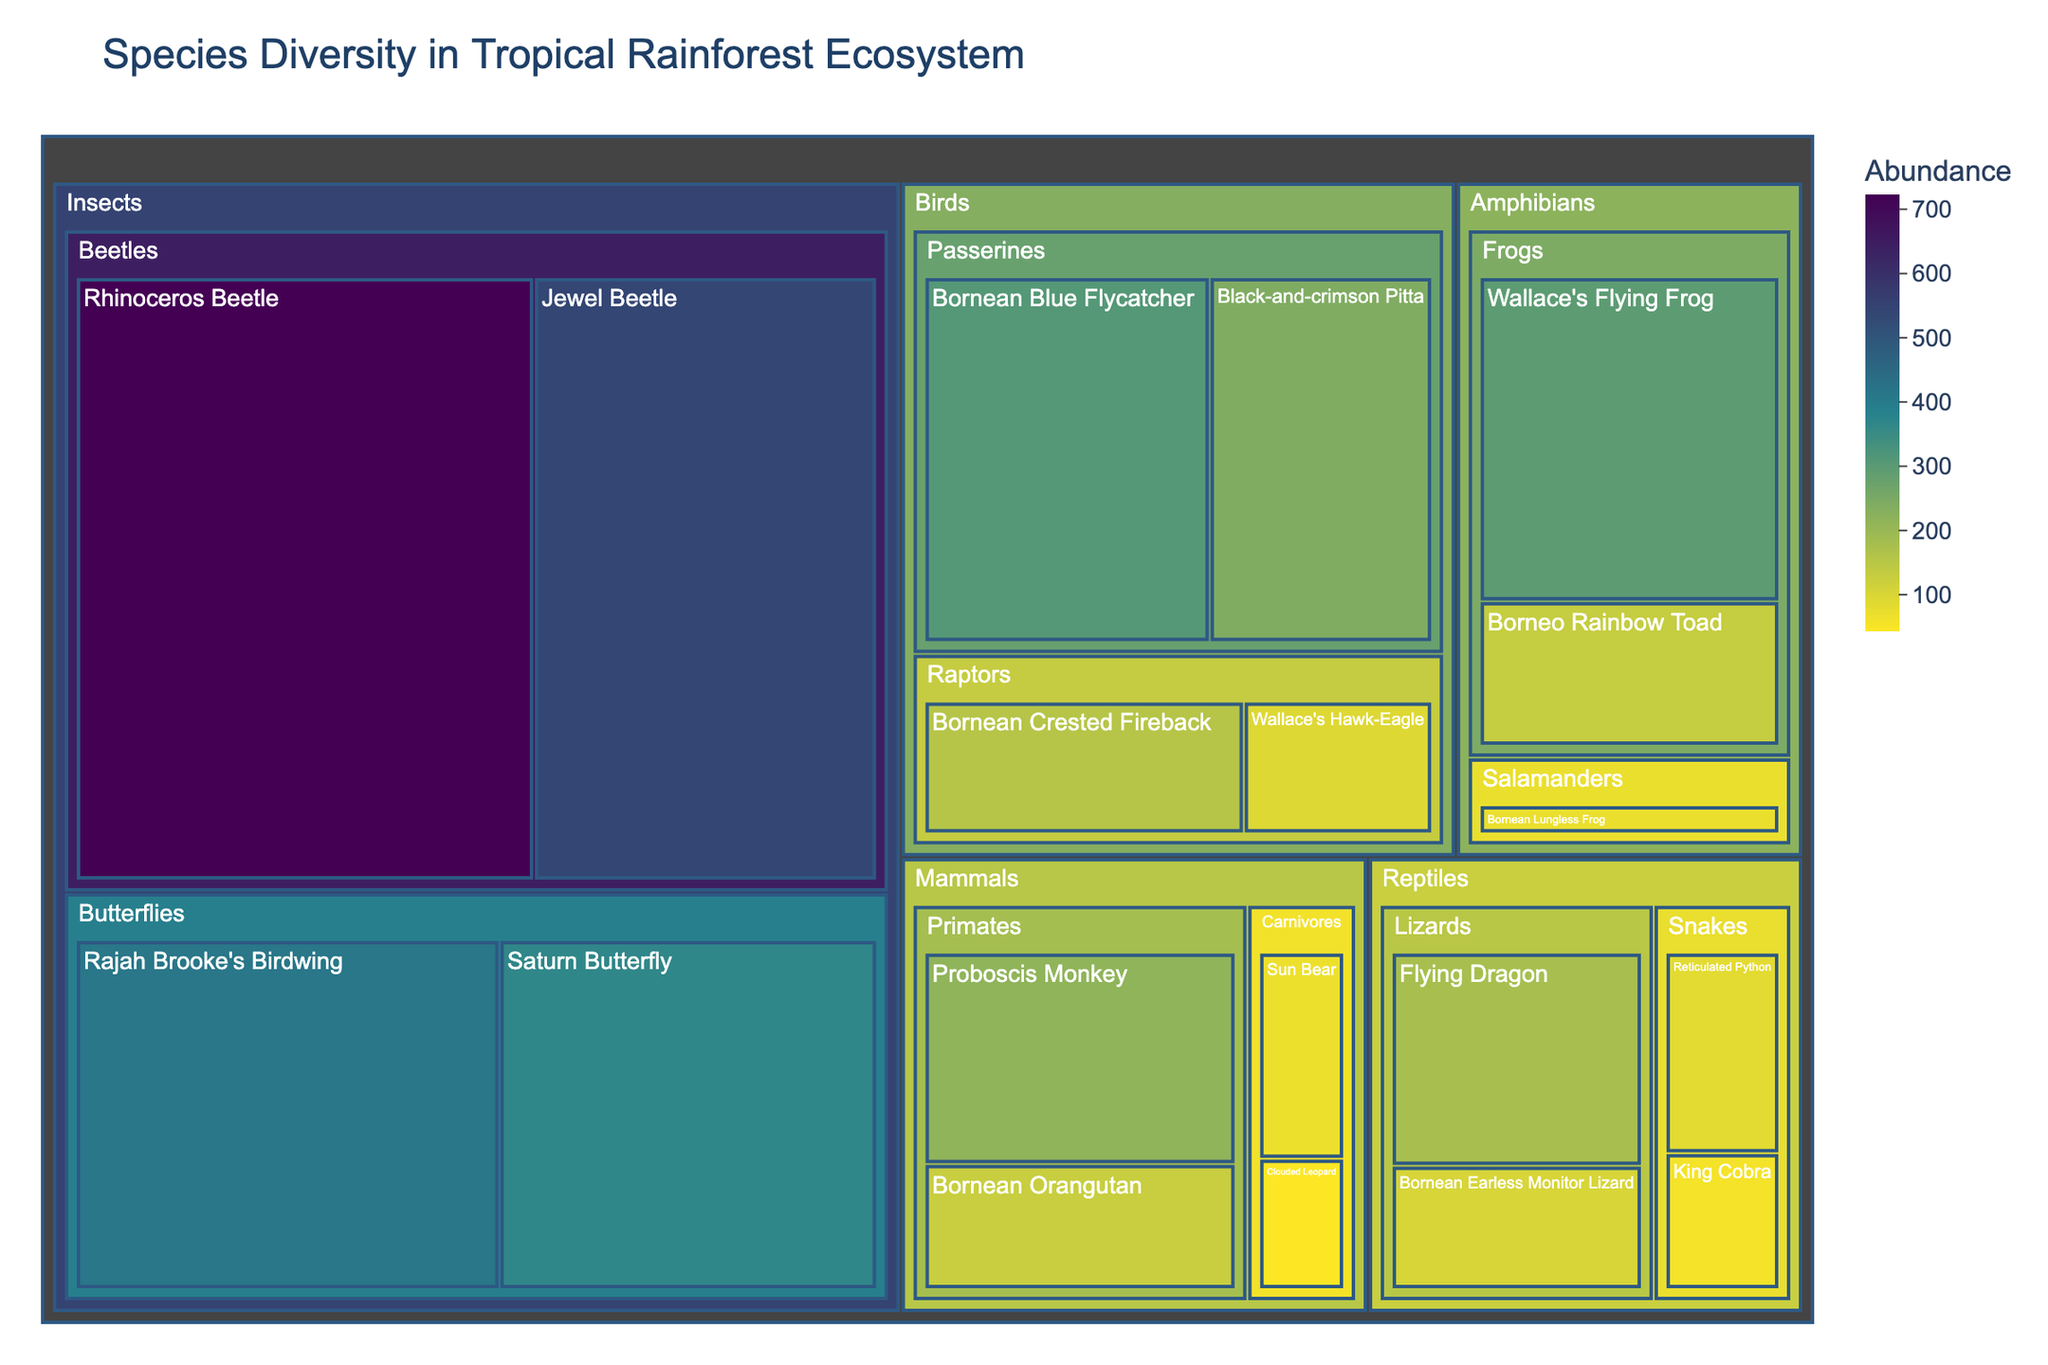What is the title of the treemap? The title is displayed at the top of the treemap, often in a larger font size.
Answer: Species Diversity in Tropical Rainforest Ecosystem Which species of mammals has the highest abundance in the treemap? Look at the separate sections for mammals and check the abundance value for each species.
Answer: Proboscis Monkey Which taxonomic group, Amphibians or Reptiles, has a higher overall abundance? Sum the abundance values of all species within Amphibians and Reptiles and compare the totals. Amphibians: 296 + 132 + 71 = 499. Reptiles: 84 + 57 + 103 + 178 = 422. Amphibians have a higher abundance.
Answer: Amphibians What is the abundance of Wallace's Hawk-Eagle? Locate the species within the Birds category and check its abundance value.
Answer: 92 Which taxonomic group has the greatest diversity of species? Count the number of distinct species within each taxonomic group. Insects have 4 species, Reptiles have 4 species, Mammals have 4 species, Birds have 4 species, Amphibians have 3 species.
Answer: Tie among Insects, Reptiles, Mammals, and Birds Between the categories Primates and Raptors, which has a greater total abundance of species? Add the abundance values for all species within the Primates and Raptors subcategories. Primates: 127 + 215 = 342. Raptors: 156 + 92 = 248.
Answer: Primates How does the abundance of the Bornean Blue Flycatcher compare to the Bornean Crested Fireback? Look at their respective abundance values and compare. The Bornean Blue Flycatcher has 309, while the Bornean Crested Fireback has 156.
Answer: Bornean Blue Flycatcher is higher What is the least abundant species in the Carnivores subcategory? Look within the Carnivores subcategory and identify the species with the lowest abundance. Clouded Leopard: 43, Sun Bear: 68.
Answer: Clouded Leopard What is the average abundance of all species listed under Butterflies? Add abundance values of all species in the Butterflies subcategory and divide by the number of species. Rajah Brooke's Birdwing: 412, Saturn Butterfly: 367. Total = 412 + 367 = 779. Average: 779 / 2 = 389.5
Answer: 389.5 Is the abundance of the Rhinoceros Beetle greater than the combined abundance of all Amphibian species? Compare the abundance of Rhinoceros Beetle (723) with the sum of all Amphibian species (296 + 132 + 71 = 499).
Answer: Yes 